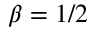Convert formula to latex. <formula><loc_0><loc_0><loc_500><loc_500>\beta = 1 / 2</formula> 